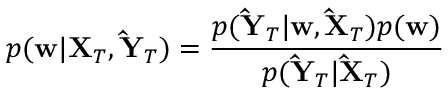<formula> <loc_0><loc_0><loc_500><loc_500>p ( w | X _ { T } , \hat { Y } _ { T } ) = \frac { p ( \hat { Y } _ { T } | w , \hat { X } _ { T } ) p ( w ) } { p ( \hat { Y } _ { T } | \hat { X } _ { T } ) }</formula> 